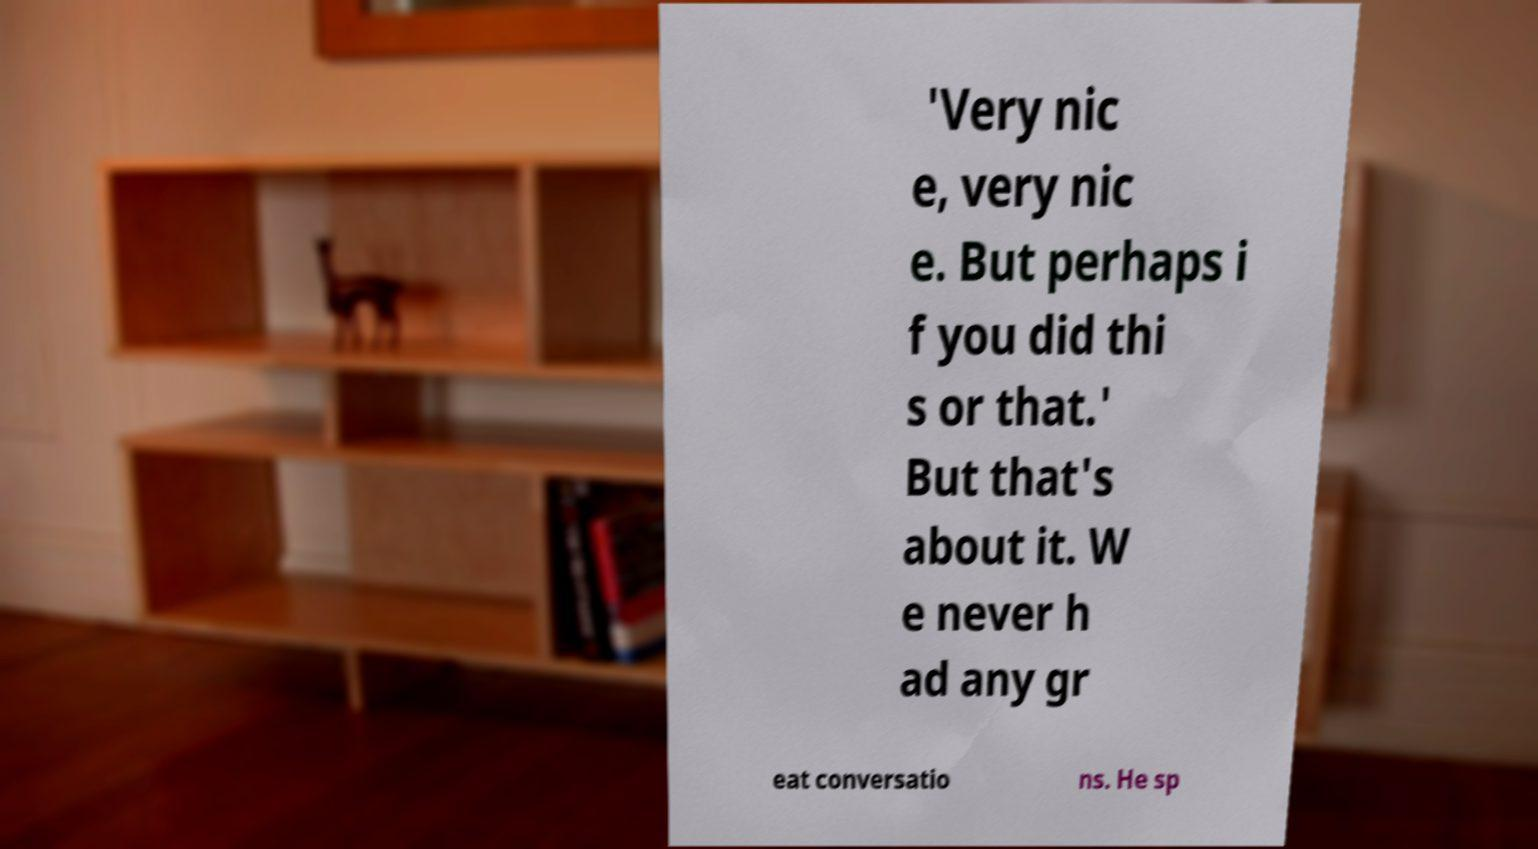Please read and relay the text visible in this image. What does it say? 'Very nic e, very nic e. But perhaps i f you did thi s or that.' But that's about it. W e never h ad any gr eat conversatio ns. He sp 